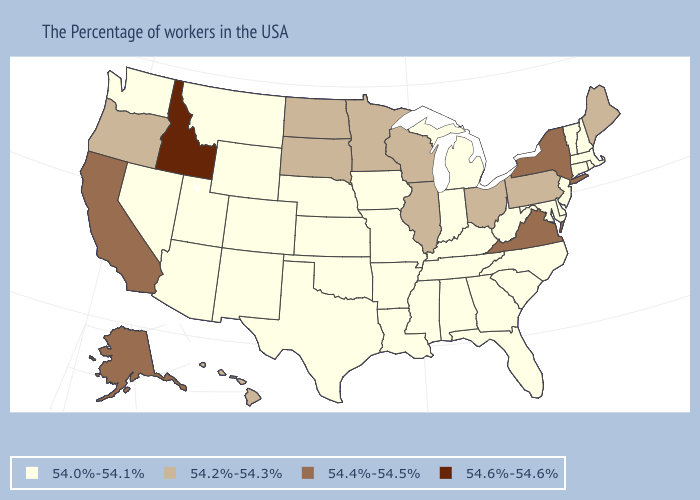Name the states that have a value in the range 54.0%-54.1%?
Quick response, please. Massachusetts, Rhode Island, New Hampshire, Vermont, Connecticut, New Jersey, Delaware, Maryland, North Carolina, South Carolina, West Virginia, Florida, Georgia, Michigan, Kentucky, Indiana, Alabama, Tennessee, Mississippi, Louisiana, Missouri, Arkansas, Iowa, Kansas, Nebraska, Oklahoma, Texas, Wyoming, Colorado, New Mexico, Utah, Montana, Arizona, Nevada, Washington. Name the states that have a value in the range 54.6%-54.6%?
Short answer required. Idaho. What is the highest value in the USA?
Quick response, please. 54.6%-54.6%. How many symbols are there in the legend?
Answer briefly. 4. Does Massachusetts have the lowest value in the Northeast?
Concise answer only. Yes. Does the first symbol in the legend represent the smallest category?
Short answer required. Yes. Name the states that have a value in the range 54.4%-54.5%?
Give a very brief answer. New York, Virginia, California, Alaska. Which states have the highest value in the USA?
Short answer required. Idaho. What is the value of Oklahoma?
Keep it brief. 54.0%-54.1%. Does Delaware have the highest value in the South?
Give a very brief answer. No. Does Idaho have the highest value in the USA?
Answer briefly. Yes. How many symbols are there in the legend?
Keep it brief. 4. Does the first symbol in the legend represent the smallest category?
Be succinct. Yes. Among the states that border Maine , which have the highest value?
Be succinct. New Hampshire. Does Maryland have the highest value in the USA?
Short answer required. No. 